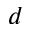Convert formula to latex. <formula><loc_0><loc_0><loc_500><loc_500>d</formula> 